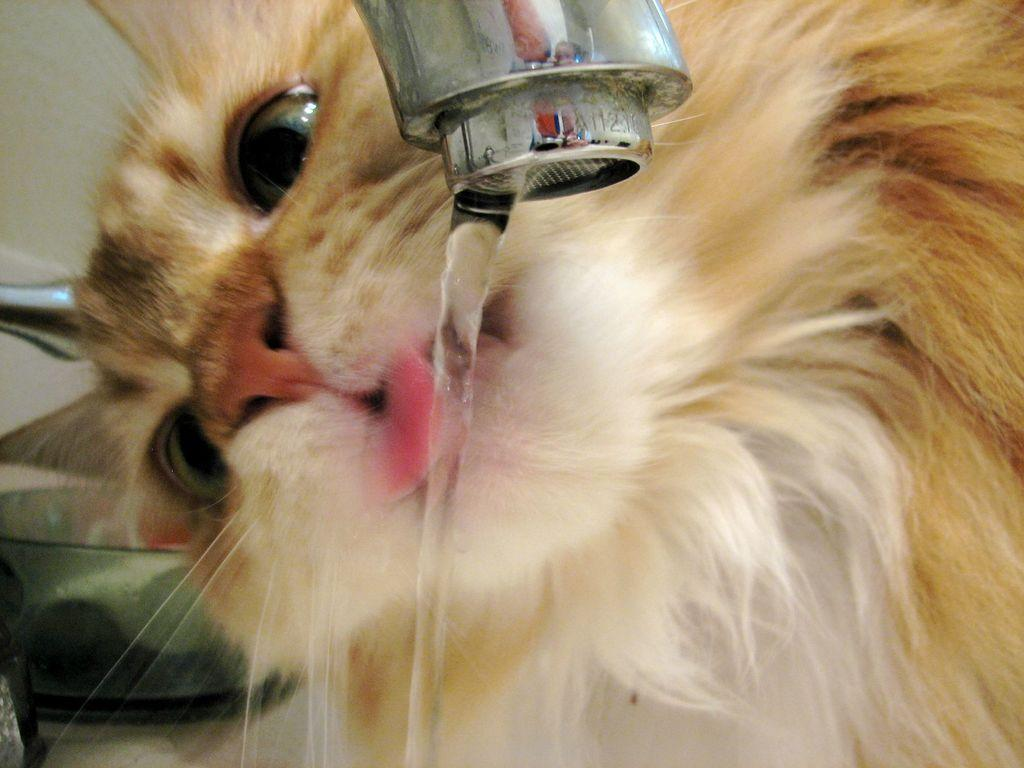What type of animal is in the image? There is a brown cat in the image. What is the cat doing in the image? The cat is drinking water. Where is the water coming from that the cat is drinking? The water is coming from a tap. What caption would best describe the image? There is no caption provided with the image, so it cannot be determined. How many frogs are present in the image? There are no frogs present in the image; it features a brown cat drinking water from a tap. 